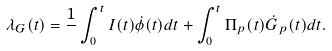Convert formula to latex. <formula><loc_0><loc_0><loc_500><loc_500>\lambda _ { G } ( t ) = \frac { 1 } { } \int _ { 0 } ^ { t } I ( t ) \dot { \phi } ( t ) d t + \int _ { 0 } ^ { t } \Pi _ { p } ( t ) \dot { G } _ { p } ( t ) d t .</formula> 